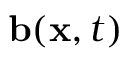Convert formula to latex. <formula><loc_0><loc_0><loc_500><loc_500>b ( x , t )</formula> 